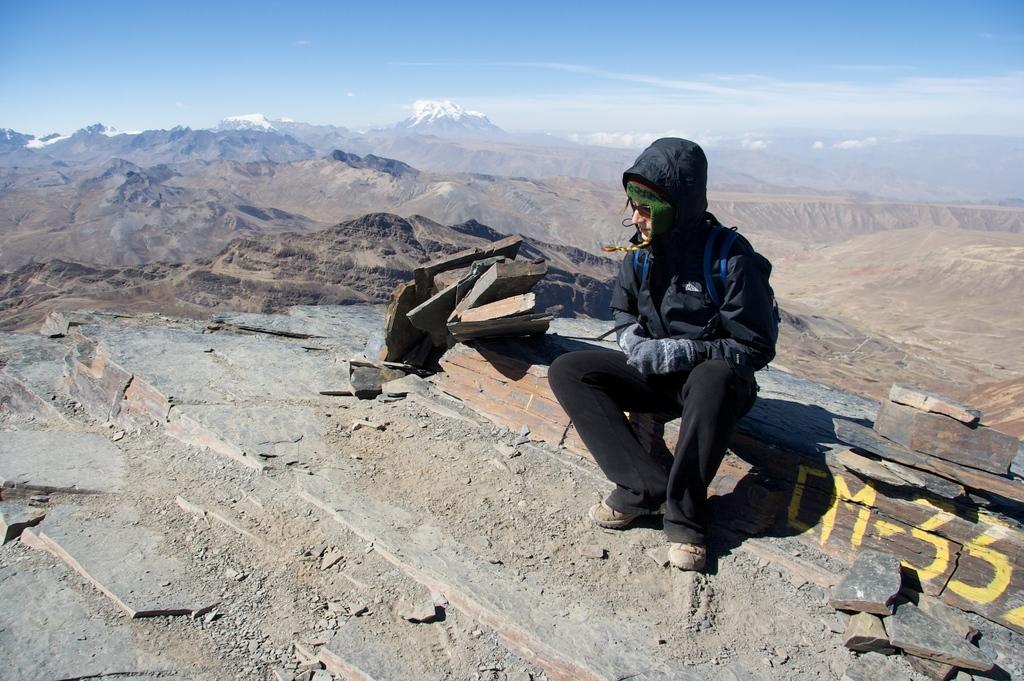Describe this image in one or two sentences. In this image we can see a person sitting on a rock. On the rock we can see some text. Behind the person we can see the mountains. At the top we can see the sky. 